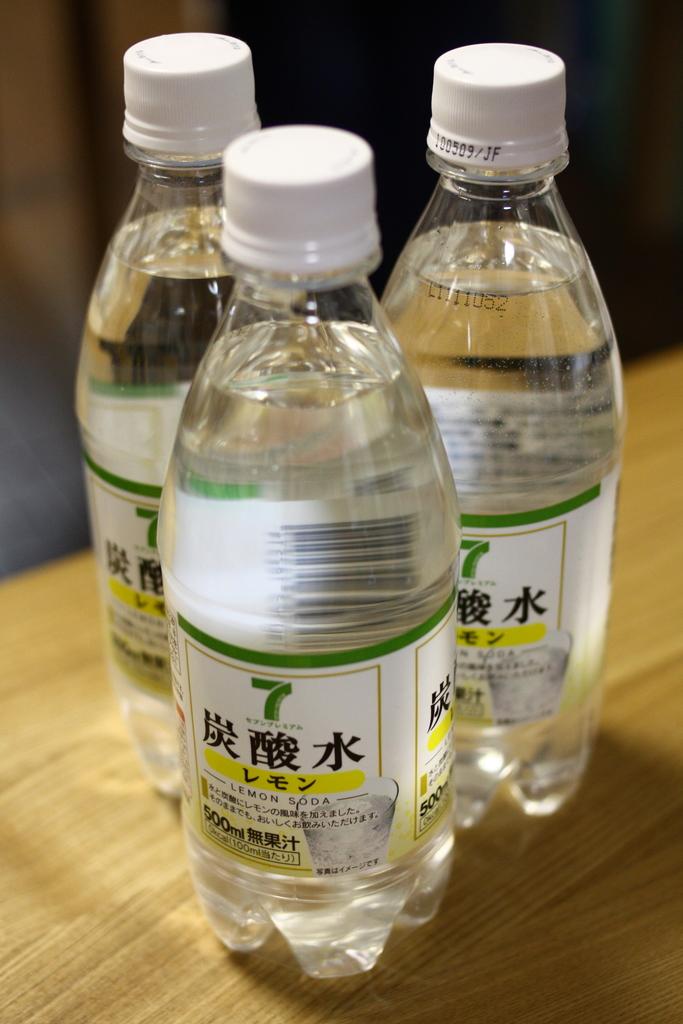What brand of water is this?
Your answer should be very brief. 7. 